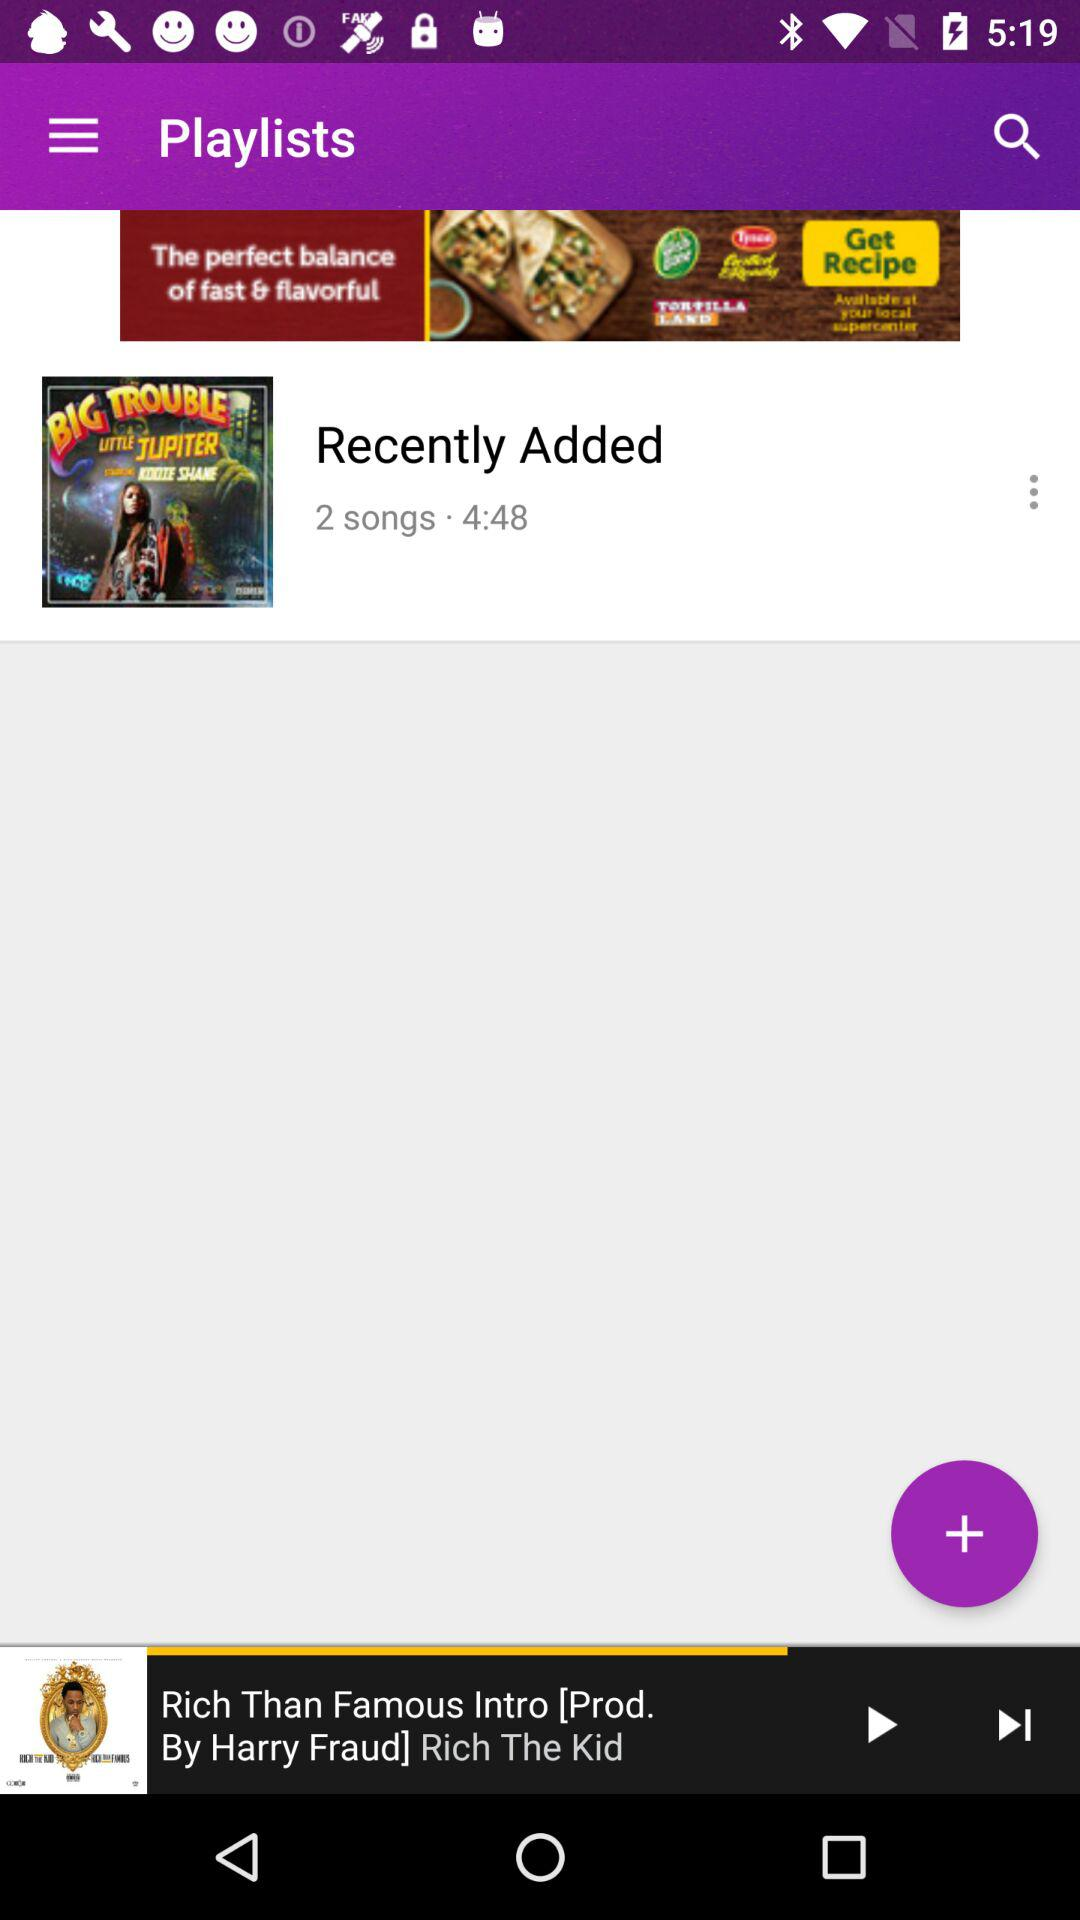How many songs have been added recently? There are two songs that have been added recently. 